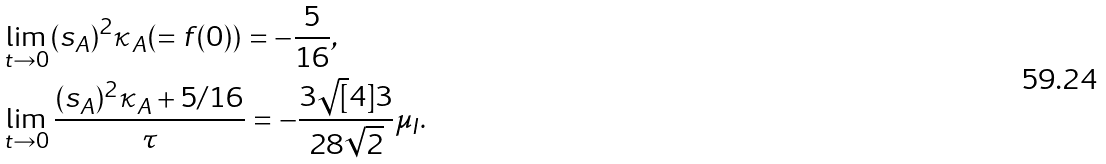Convert formula to latex. <formula><loc_0><loc_0><loc_500><loc_500>& \lim _ { t \to 0 } ( s _ { A } ) ^ { 2 } \kappa _ { A } ( = f ( 0 ) ) = - \frac { 5 } { 1 6 } , \\ & \lim _ { t \to 0 } \frac { ( s _ { A } ) ^ { 2 } \kappa _ { A } + { 5 } / { 1 6 } } { \tau } = - \frac { 3 \sqrt { [ } 4 ] { 3 } } { 2 8 \sqrt { 2 } } \mu _ { I } .</formula> 